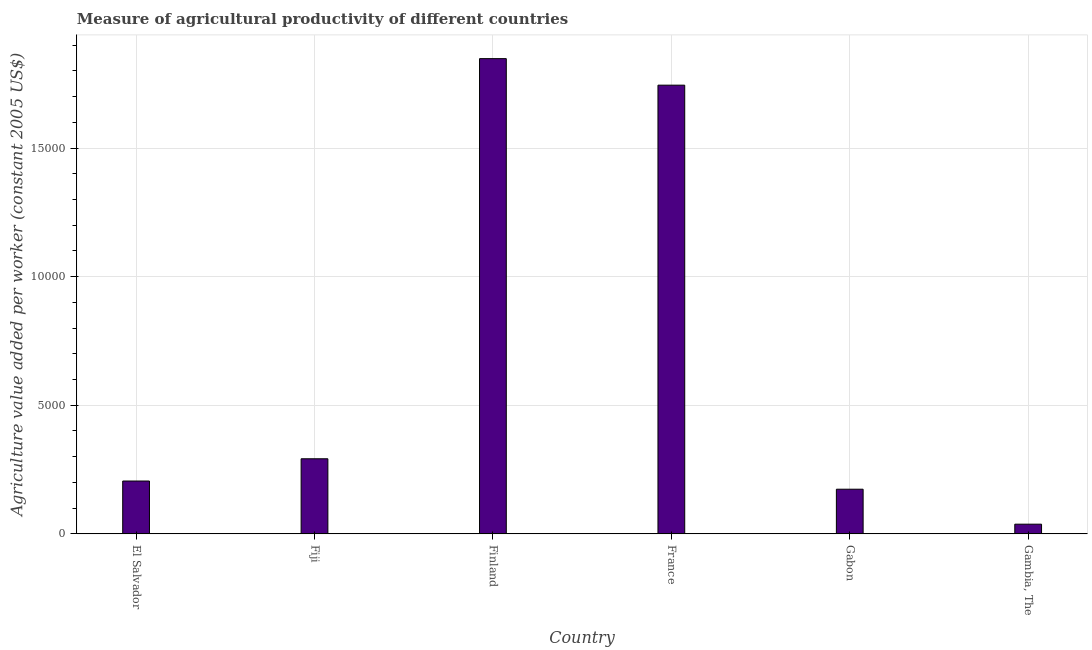Does the graph contain any zero values?
Give a very brief answer. No. What is the title of the graph?
Keep it short and to the point. Measure of agricultural productivity of different countries. What is the label or title of the X-axis?
Ensure brevity in your answer.  Country. What is the label or title of the Y-axis?
Your answer should be very brief. Agriculture value added per worker (constant 2005 US$). What is the agriculture value added per worker in Gabon?
Ensure brevity in your answer.  1735.82. Across all countries, what is the maximum agriculture value added per worker?
Offer a very short reply. 1.85e+04. Across all countries, what is the minimum agriculture value added per worker?
Make the answer very short. 376.46. In which country was the agriculture value added per worker minimum?
Keep it short and to the point. Gambia, The. What is the sum of the agriculture value added per worker?
Your response must be concise. 4.30e+04. What is the difference between the agriculture value added per worker in Gabon and Gambia, The?
Make the answer very short. 1359.36. What is the average agriculture value added per worker per country?
Offer a terse response. 7167.44. What is the median agriculture value added per worker?
Your answer should be compact. 2486.73. What is the ratio of the agriculture value added per worker in Fiji to that in Finland?
Offer a very short reply. 0.16. Is the difference between the agriculture value added per worker in Fiji and Gambia, The greater than the difference between any two countries?
Your answer should be compact. No. What is the difference between the highest and the second highest agriculture value added per worker?
Keep it short and to the point. 1031.29. What is the difference between the highest and the lowest agriculture value added per worker?
Ensure brevity in your answer.  1.81e+04. In how many countries, is the agriculture value added per worker greater than the average agriculture value added per worker taken over all countries?
Provide a short and direct response. 2. What is the Agriculture value added per worker (constant 2005 US$) of El Salvador?
Keep it short and to the point. 2054.33. What is the Agriculture value added per worker (constant 2005 US$) of Fiji?
Give a very brief answer. 2919.12. What is the Agriculture value added per worker (constant 2005 US$) in Finland?
Your answer should be very brief. 1.85e+04. What is the Agriculture value added per worker (constant 2005 US$) of France?
Make the answer very short. 1.74e+04. What is the Agriculture value added per worker (constant 2005 US$) in Gabon?
Offer a very short reply. 1735.82. What is the Agriculture value added per worker (constant 2005 US$) in Gambia, The?
Your response must be concise. 376.46. What is the difference between the Agriculture value added per worker (constant 2005 US$) in El Salvador and Fiji?
Provide a succinct answer. -864.8. What is the difference between the Agriculture value added per worker (constant 2005 US$) in El Salvador and Finland?
Give a very brief answer. -1.64e+04. What is the difference between the Agriculture value added per worker (constant 2005 US$) in El Salvador and France?
Offer a very short reply. -1.54e+04. What is the difference between the Agriculture value added per worker (constant 2005 US$) in El Salvador and Gabon?
Your response must be concise. 318.5. What is the difference between the Agriculture value added per worker (constant 2005 US$) in El Salvador and Gambia, The?
Give a very brief answer. 1677.86. What is the difference between the Agriculture value added per worker (constant 2005 US$) in Fiji and Finland?
Provide a short and direct response. -1.56e+04. What is the difference between the Agriculture value added per worker (constant 2005 US$) in Fiji and France?
Give a very brief answer. -1.45e+04. What is the difference between the Agriculture value added per worker (constant 2005 US$) in Fiji and Gabon?
Your answer should be very brief. 1183.3. What is the difference between the Agriculture value added per worker (constant 2005 US$) in Fiji and Gambia, The?
Give a very brief answer. 2542.66. What is the difference between the Agriculture value added per worker (constant 2005 US$) in Finland and France?
Your response must be concise. 1031.29. What is the difference between the Agriculture value added per worker (constant 2005 US$) in Finland and Gabon?
Provide a succinct answer. 1.67e+04. What is the difference between the Agriculture value added per worker (constant 2005 US$) in Finland and Gambia, The?
Your response must be concise. 1.81e+04. What is the difference between the Agriculture value added per worker (constant 2005 US$) in France and Gabon?
Your answer should be compact. 1.57e+04. What is the difference between the Agriculture value added per worker (constant 2005 US$) in France and Gambia, The?
Offer a very short reply. 1.71e+04. What is the difference between the Agriculture value added per worker (constant 2005 US$) in Gabon and Gambia, The?
Provide a short and direct response. 1359.36. What is the ratio of the Agriculture value added per worker (constant 2005 US$) in El Salvador to that in Fiji?
Make the answer very short. 0.7. What is the ratio of the Agriculture value added per worker (constant 2005 US$) in El Salvador to that in Finland?
Offer a very short reply. 0.11. What is the ratio of the Agriculture value added per worker (constant 2005 US$) in El Salvador to that in France?
Give a very brief answer. 0.12. What is the ratio of the Agriculture value added per worker (constant 2005 US$) in El Salvador to that in Gabon?
Your response must be concise. 1.18. What is the ratio of the Agriculture value added per worker (constant 2005 US$) in El Salvador to that in Gambia, The?
Your answer should be very brief. 5.46. What is the ratio of the Agriculture value added per worker (constant 2005 US$) in Fiji to that in Finland?
Keep it short and to the point. 0.16. What is the ratio of the Agriculture value added per worker (constant 2005 US$) in Fiji to that in France?
Make the answer very short. 0.17. What is the ratio of the Agriculture value added per worker (constant 2005 US$) in Fiji to that in Gabon?
Your response must be concise. 1.68. What is the ratio of the Agriculture value added per worker (constant 2005 US$) in Fiji to that in Gambia, The?
Keep it short and to the point. 7.75. What is the ratio of the Agriculture value added per worker (constant 2005 US$) in Finland to that in France?
Your response must be concise. 1.06. What is the ratio of the Agriculture value added per worker (constant 2005 US$) in Finland to that in Gabon?
Your answer should be very brief. 10.64. What is the ratio of the Agriculture value added per worker (constant 2005 US$) in Finland to that in Gambia, The?
Keep it short and to the point. 49.08. What is the ratio of the Agriculture value added per worker (constant 2005 US$) in France to that in Gabon?
Make the answer very short. 10.05. What is the ratio of the Agriculture value added per worker (constant 2005 US$) in France to that in Gambia, The?
Offer a very short reply. 46.34. What is the ratio of the Agriculture value added per worker (constant 2005 US$) in Gabon to that in Gambia, The?
Your response must be concise. 4.61. 